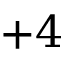<formula> <loc_0><loc_0><loc_500><loc_500>+ 4</formula> 